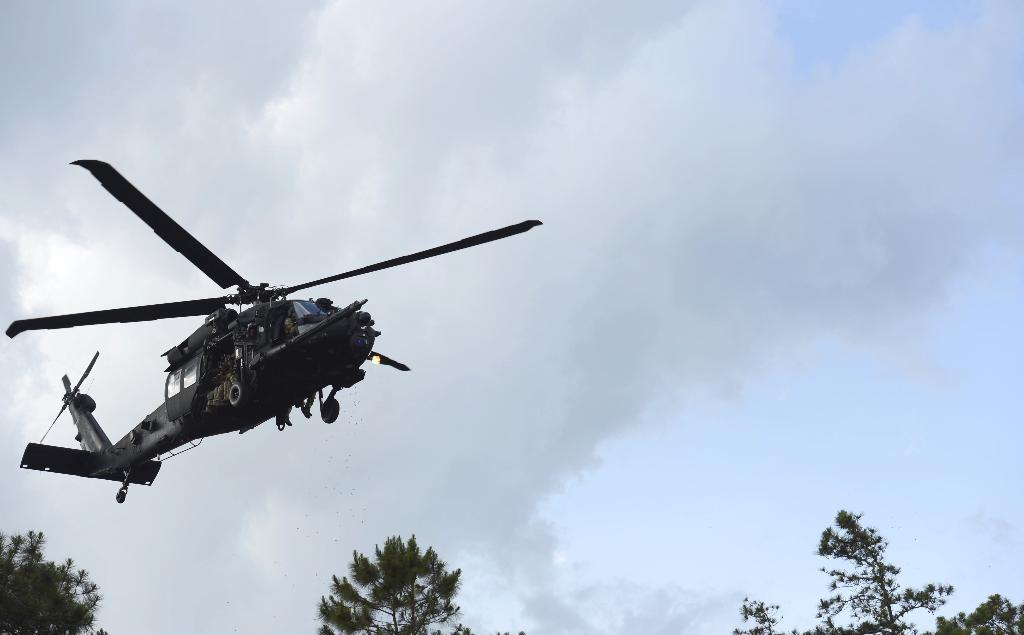What is the main subject of the picture? The main subject of the picture is a helicopter. What is the helicopter doing in the image? The helicopter is flying in the air. What can be seen in the background of the image? There are trees and a cloudy sky in the background of the image. Can you see any nerves in the helicopter's structure in the image? There are no nerves present in the helicopter's structure, as it is a mechanical object and not a living organism. 